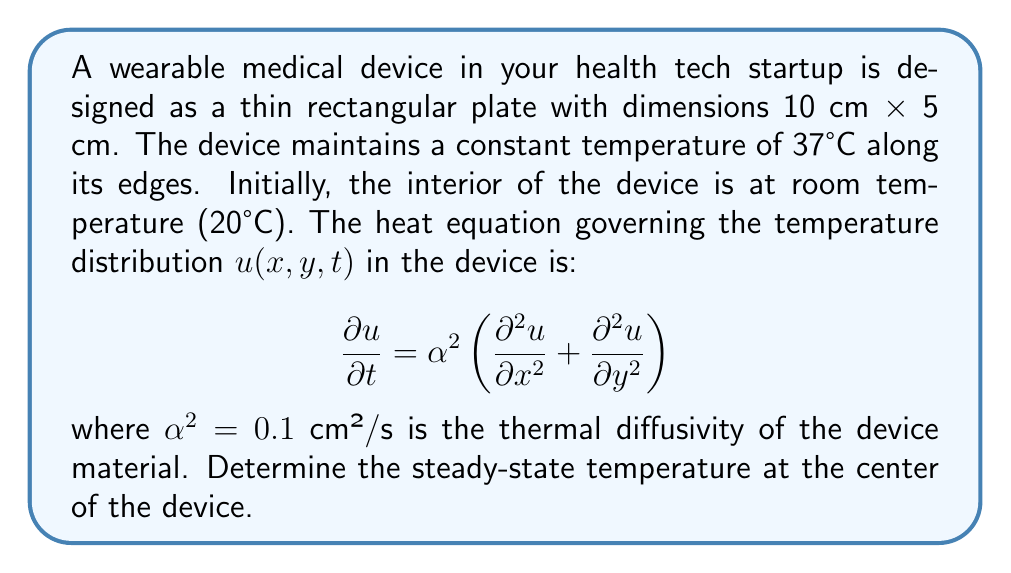Can you solve this math problem? To solve this problem, we need to follow these steps:

1) For the steady-state solution, the temperature doesn't change with time, so $\frac{\partial u}{\partial t} = 0$. The heat equation reduces to:

   $$\frac{\partial^2 u}{\partial x^2} + \frac{\partial^2 u}{\partial y^2} = 0$$

2) This is Laplace's equation in 2D. Given the rectangular shape and constant temperature boundary conditions, we can use the separation of variables method.

3) The general solution for this problem is:

   $$u(x,y) = 37 - \sum_{n=1,3,5,...}^{\infty} \frac{4(37-20)}{\pi n} \sin(\frac{n\pi x}{10}) \sinh(\frac{n\pi y}{10}) \frac{\sinh(\frac{n\pi(5-y)}{10})}{\sinh(\frac{5n\pi}{10})}$$

4) At the center of the device, $x = 5$ cm and $y = 2.5$ cm. Substituting these values:

   $$u(5,2.5) = 37 - \sum_{n=1,3,5,...}^{\infty} \frac{4(17)}{\pi n} \sin(\frac{n\pi}{2}) \sinh(\frac{n\pi}{4}) \frac{\sinh(\frac{n\pi}{4})}{\sinh(\frac{n\pi}{2})}$$

5) Simplify:
   
   $$u(5,2.5) = 37 - \frac{68}{\pi} \sum_{n=1,3,5,...}^{\infty} \frac{1}{n} \sin(\frac{n\pi}{2}) \frac{\sinh^2(\frac{n\pi}{4})}{\sinh(\frac{n\pi}{2})}$$

6) Calculate the first few terms of this series:
   For n = 1: $\frac{68}{\pi} \cdot 1 \cdot \frac{\sinh^2(\frac{\pi}{4})}{\sinh(\frac{\pi}{2})} \approx 13.6041$
   For n = 3: $\frac{68}{3\pi} \cdot (-1) \cdot \frac{\sinh^2(\frac{3\pi}{4})}{\sinh(\frac{3\pi}{2})} \approx -0.1505$
   For n = 5: $\frac{68}{5\pi} \cdot 1 \cdot \frac{\sinh^2(\frac{5\pi}{4})}{\sinh(\frac{5\pi}{2})} \approx 0.0017$

7) The series converges rapidly. Summing these terms:

   $$u(5,2.5) \approx 37 - (13.6041 - 0.1505 + 0.0017) \approx 23.5447°C$$
Answer: 23.54°C 